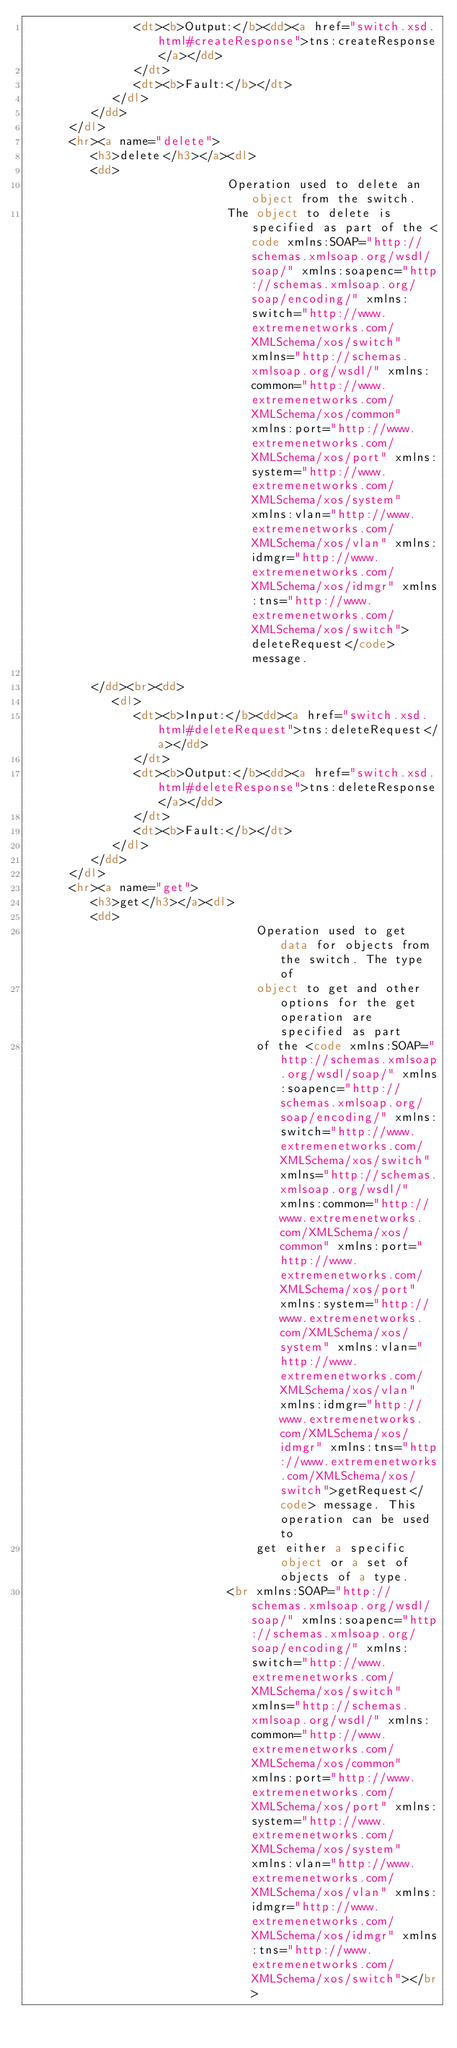<code> <loc_0><loc_0><loc_500><loc_500><_HTML_>               <dt><b>Output:</b><dd><a href="switch.xsd.html#createResponse">tns:createResponse</a></dd>
               </dt>
               <dt><b>Fault:</b></dt>
            </dl>
         </dd>
      </dl>
      <hr><a name="delete">
         <h3>delete</h3></a><dl>
         <dd>
            				Operation used to delete an object from the switch. 
            				The object to delete is specified as part of the <code xmlns:SOAP="http://schemas.xmlsoap.org/wsdl/soap/" xmlns:soapenc="http://schemas.xmlsoap.org/soap/encoding/" xmlns:switch="http://www.extremenetworks.com/XMLSchema/xos/switch" xmlns="http://schemas.xmlsoap.org/wsdl/" xmlns:common="http://www.extremenetworks.com/XMLSchema/xos/common" xmlns:port="http://www.extremenetworks.com/XMLSchema/xos/port" xmlns:system="http://www.extremenetworks.com/XMLSchema/xos/system" xmlns:vlan="http://www.extremenetworks.com/XMLSchema/xos/vlan" xmlns:idmgr="http://www.extremenetworks.com/XMLSchema/xos/idmgr" xmlns:tns="http://www.extremenetworks.com/XMLSchema/xos/switch">deleteRequest</code> message.
            
         </dd><br><dd>
            <dl>
               <dt><b>Input:</b><dd><a href="switch.xsd.html#deleteRequest">tns:deleteRequest</a></dd>
               </dt>
               <dt><b>Output:</b><dd><a href="switch.xsd.html#deleteResponse">tns:deleteResponse</a></dd>
               </dt>
               <dt><b>Fault:</b></dt>
            </dl>
         </dd>
      </dl>
      <hr><a name="get">
         <h3>get</h3></a><dl>
         <dd>
            					Operation used to get data for objects from the switch. The type of 
            					object to get and other options for the get operation are specified as part 
            					of the <code xmlns:SOAP="http://schemas.xmlsoap.org/wsdl/soap/" xmlns:soapenc="http://schemas.xmlsoap.org/soap/encoding/" xmlns:switch="http://www.extremenetworks.com/XMLSchema/xos/switch" xmlns="http://schemas.xmlsoap.org/wsdl/" xmlns:common="http://www.extremenetworks.com/XMLSchema/xos/common" xmlns:port="http://www.extremenetworks.com/XMLSchema/xos/port" xmlns:system="http://www.extremenetworks.com/XMLSchema/xos/system" xmlns:vlan="http://www.extremenetworks.com/XMLSchema/xos/vlan" xmlns:idmgr="http://www.extremenetworks.com/XMLSchema/xos/idmgr" xmlns:tns="http://www.extremenetworks.com/XMLSchema/xos/switch">getRequest</code> message. This operation can be used to 
            					get either a specific object or a set of objects of a type.
            				<br xmlns:SOAP="http://schemas.xmlsoap.org/wsdl/soap/" xmlns:soapenc="http://schemas.xmlsoap.org/soap/encoding/" xmlns:switch="http://www.extremenetworks.com/XMLSchema/xos/switch" xmlns="http://schemas.xmlsoap.org/wsdl/" xmlns:common="http://www.extremenetworks.com/XMLSchema/xos/common" xmlns:port="http://www.extremenetworks.com/XMLSchema/xos/port" xmlns:system="http://www.extremenetworks.com/XMLSchema/xos/system" xmlns:vlan="http://www.extremenetworks.com/XMLSchema/xos/vlan" xmlns:idmgr="http://www.extremenetworks.com/XMLSchema/xos/idmgr" xmlns:tns="http://www.extremenetworks.com/XMLSchema/xos/switch"></br></code> 